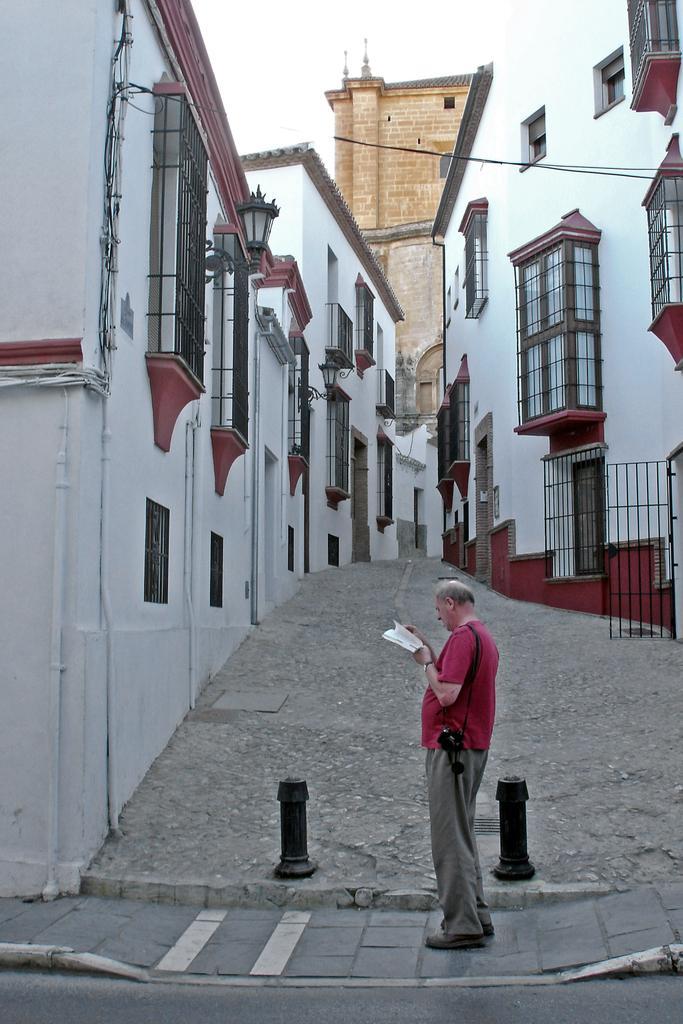Can you describe this image briefly? Here a man is standing on a footpath, these are the buildings which are in white color. 